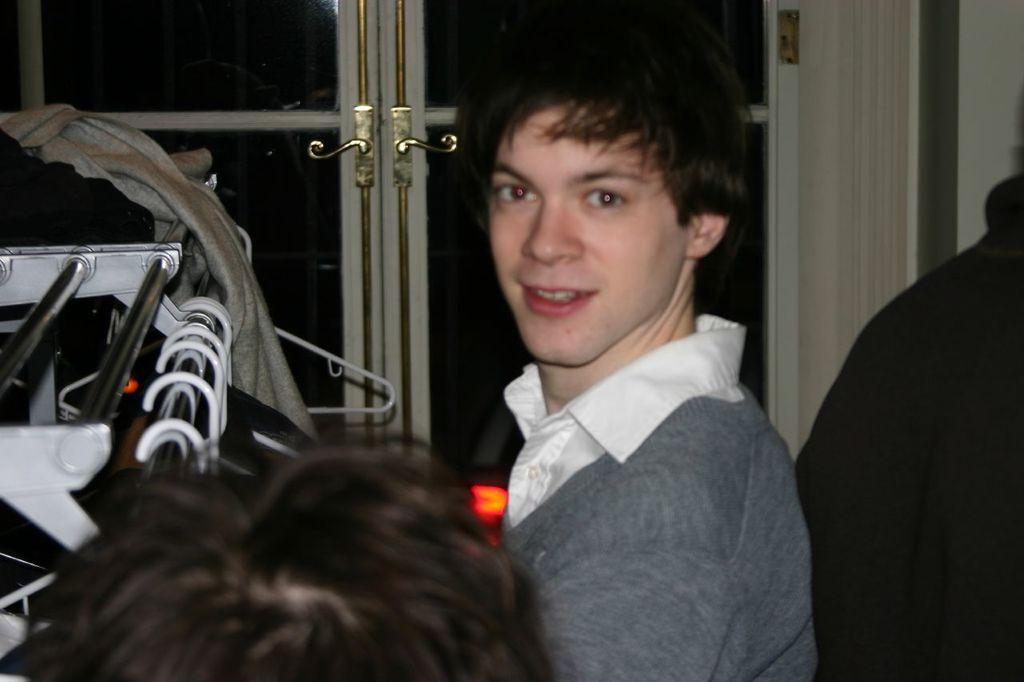How many people are in the image? There are persons in the image. Can you describe the man in the image? There is a man in the image, and he is smiling. What can be seen on the left side of the image? There are objects on the left side of the image. What type of items are visible in the image? There are clothes in the image. What architectural feature is visible in the background? There is a door in the background of the image. What type of horse can be seen working in the image? There is no horse present in the image, and therefore no such activity can be observed. Can you tell me the name of the man's son in the image? There is no mention of a son in the image, and therefore his name cannot be determined. 